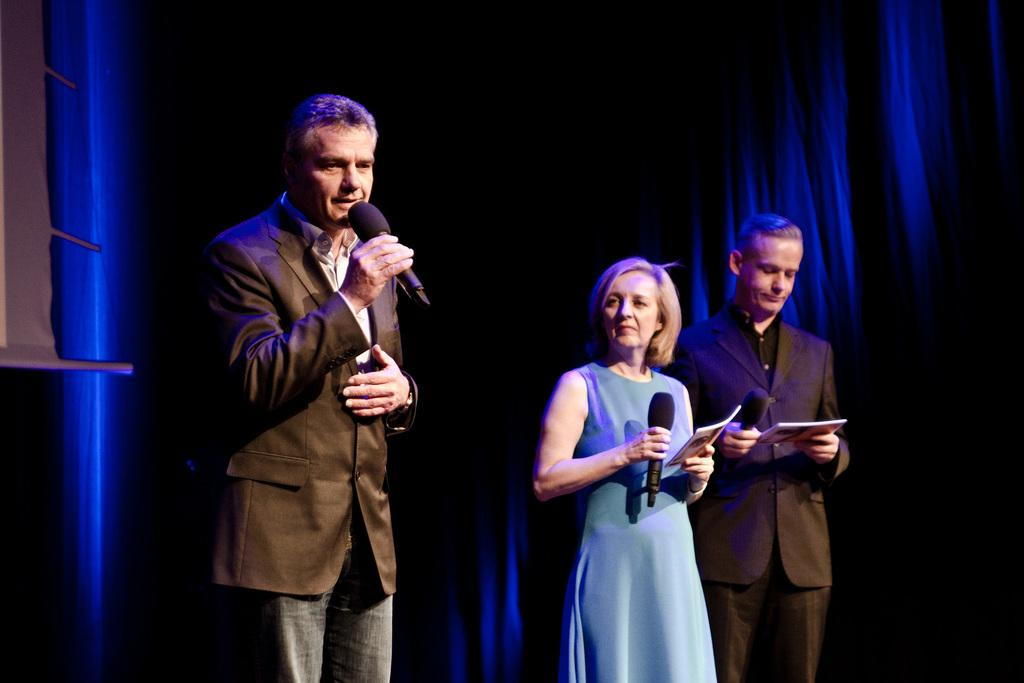How many people are present in the image? There are three people in the image, a man and a woman holding a mic, and another man standing beside them. What are the man and woman holding in the image? The man and woman are holding a mic in the image. What can be seen in the background of the image? There is a curtain in the background of the image. What type of match is being played in the image? There is no match being played in the image; it features a man and a woman holding a mic, and another man standing beside them. What book is the woman reading in the image? There is no book or reading activity present in the image. 